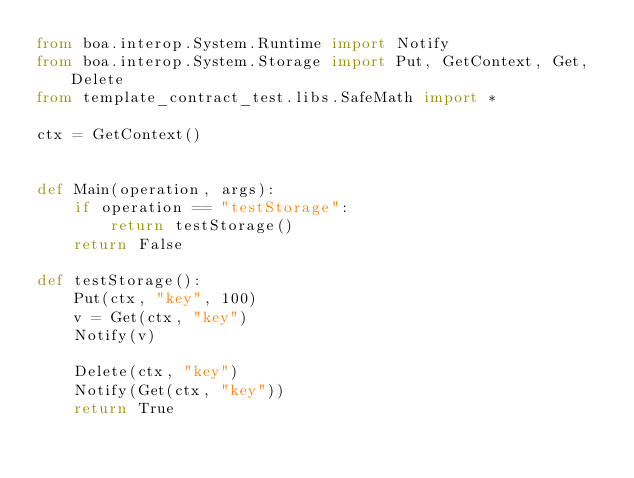<code> <loc_0><loc_0><loc_500><loc_500><_Python_>from boa.interop.System.Runtime import Notify
from boa.interop.System.Storage import Put, GetContext, Get, Delete
from template_contract_test.libs.SafeMath import *

ctx = GetContext()


def Main(operation, args):
    if operation == "testStorage":
        return testStorage()
    return False

def testStorage():
    Put(ctx, "key", 100)
    v = Get(ctx, "key")
    Notify(v)

    Delete(ctx, "key")
    Notify(Get(ctx, "key"))
    return True</code> 